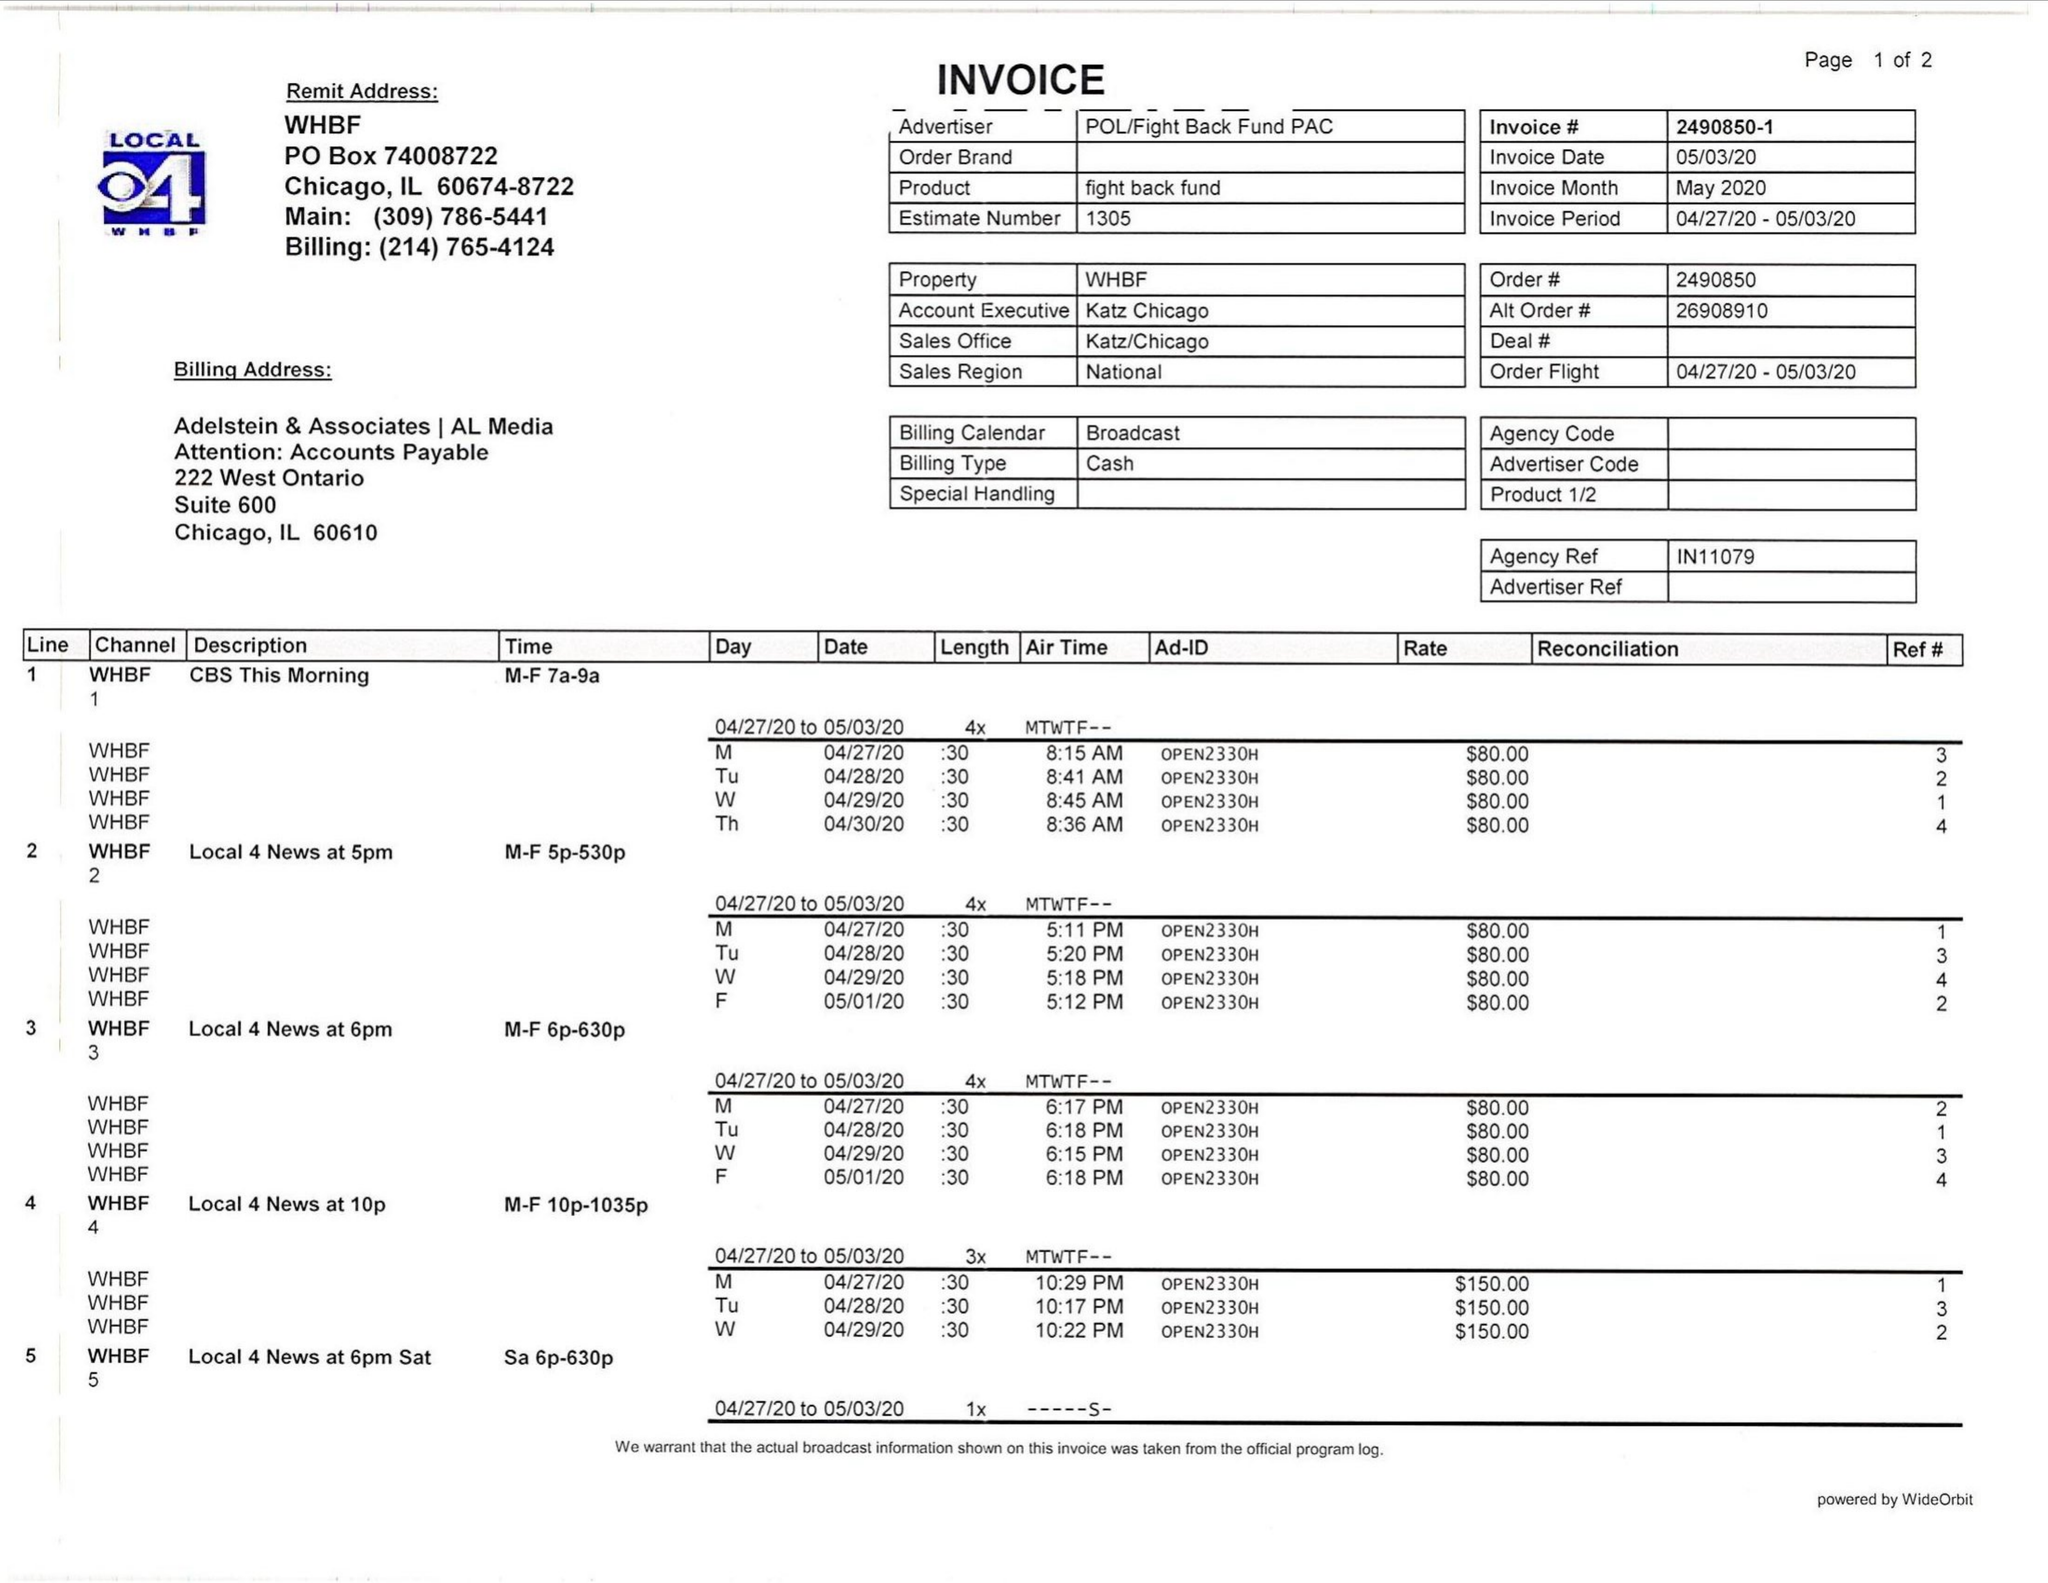What is the value for the flight_to?
Answer the question using a single word or phrase. 05/03/20 